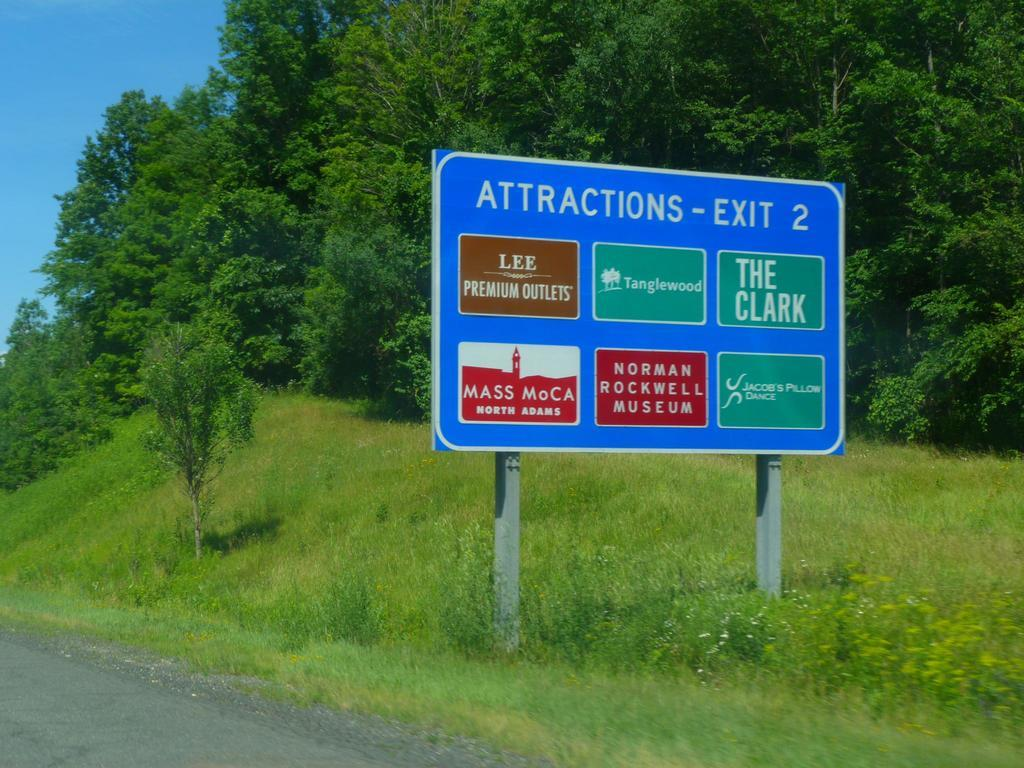<image>
Render a clear and concise summary of the photo. an attractions sign that has many labels on it 